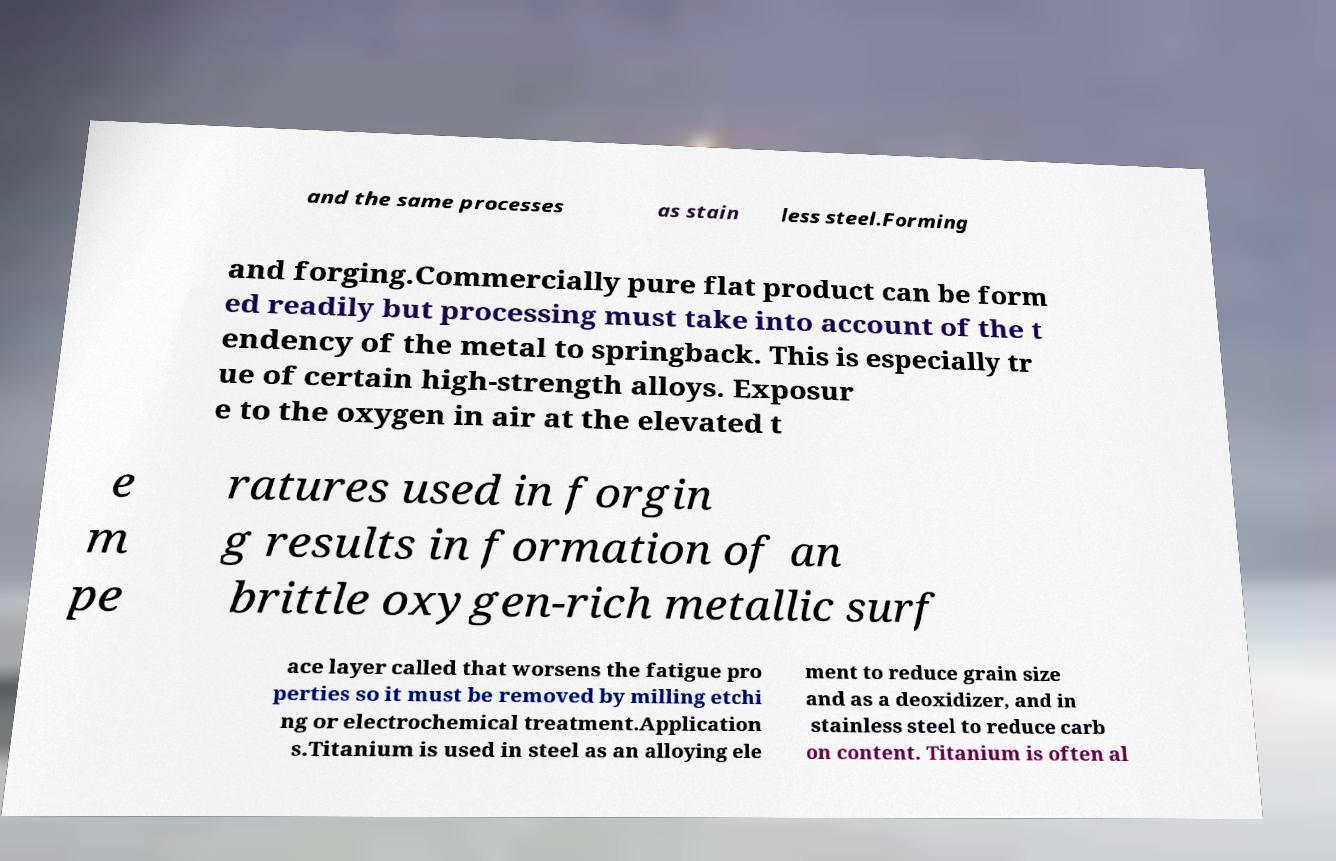I need the written content from this picture converted into text. Can you do that? and the same processes as stain less steel.Forming and forging.Commercially pure flat product can be form ed readily but processing must take into account of the t endency of the metal to springback. This is especially tr ue of certain high-strength alloys. Exposur e to the oxygen in air at the elevated t e m pe ratures used in forgin g results in formation of an brittle oxygen-rich metallic surf ace layer called that worsens the fatigue pro perties so it must be removed by milling etchi ng or electrochemical treatment.Application s.Titanium is used in steel as an alloying ele ment to reduce grain size and as a deoxidizer, and in stainless steel to reduce carb on content. Titanium is often al 